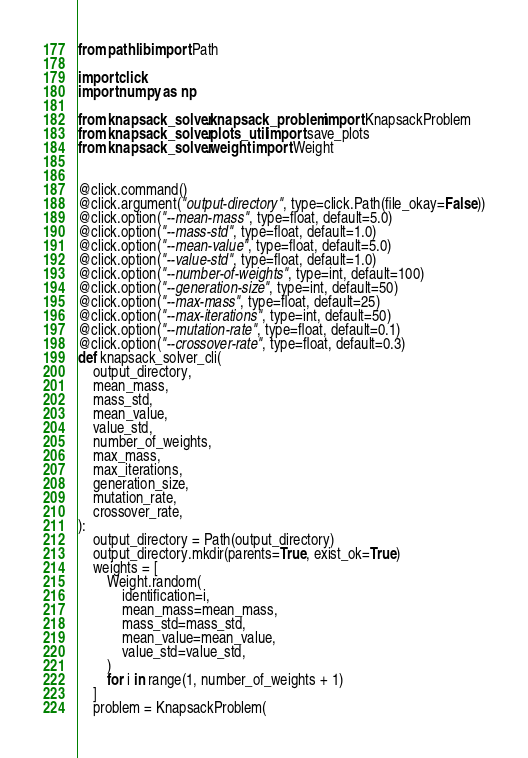Convert code to text. <code><loc_0><loc_0><loc_500><loc_500><_Python_>from pathlib import Path

import click
import numpy as np

from knapsack_solver.knapsack_problem import KnapsackProblem
from knapsack_solver.plots_util import save_plots
from knapsack_solver.weight import Weight


@click.command()
@click.argument("output-directory", type=click.Path(file_okay=False))
@click.option("--mean-mass", type=float, default=5.0)
@click.option("--mass-std", type=float, default=1.0)
@click.option("--mean-value", type=float, default=5.0)
@click.option("--value-std", type=float, default=1.0)
@click.option("--number-of-weights", type=int, default=100)
@click.option("--generation-size", type=int, default=50)
@click.option("--max-mass", type=float, default=25)
@click.option("--max-iterations", type=int, default=50)
@click.option("--mutation-rate", type=float, default=0.1)
@click.option("--crossover-rate", type=float, default=0.3)
def knapsack_solver_cli(
    output_directory,
    mean_mass,
    mass_std,
    mean_value,
    value_std,
    number_of_weights,
    max_mass,
    max_iterations,
    generation_size,
    mutation_rate,
    crossover_rate,
):
    output_directory = Path(output_directory)
    output_directory.mkdir(parents=True, exist_ok=True)
    weights = [
        Weight.random(
            identification=i,
            mean_mass=mean_mass,
            mass_std=mass_std,
            mean_value=mean_value,
            value_std=value_std,
        )
        for i in range(1, number_of_weights + 1)
    ]
    problem = KnapsackProblem(</code> 